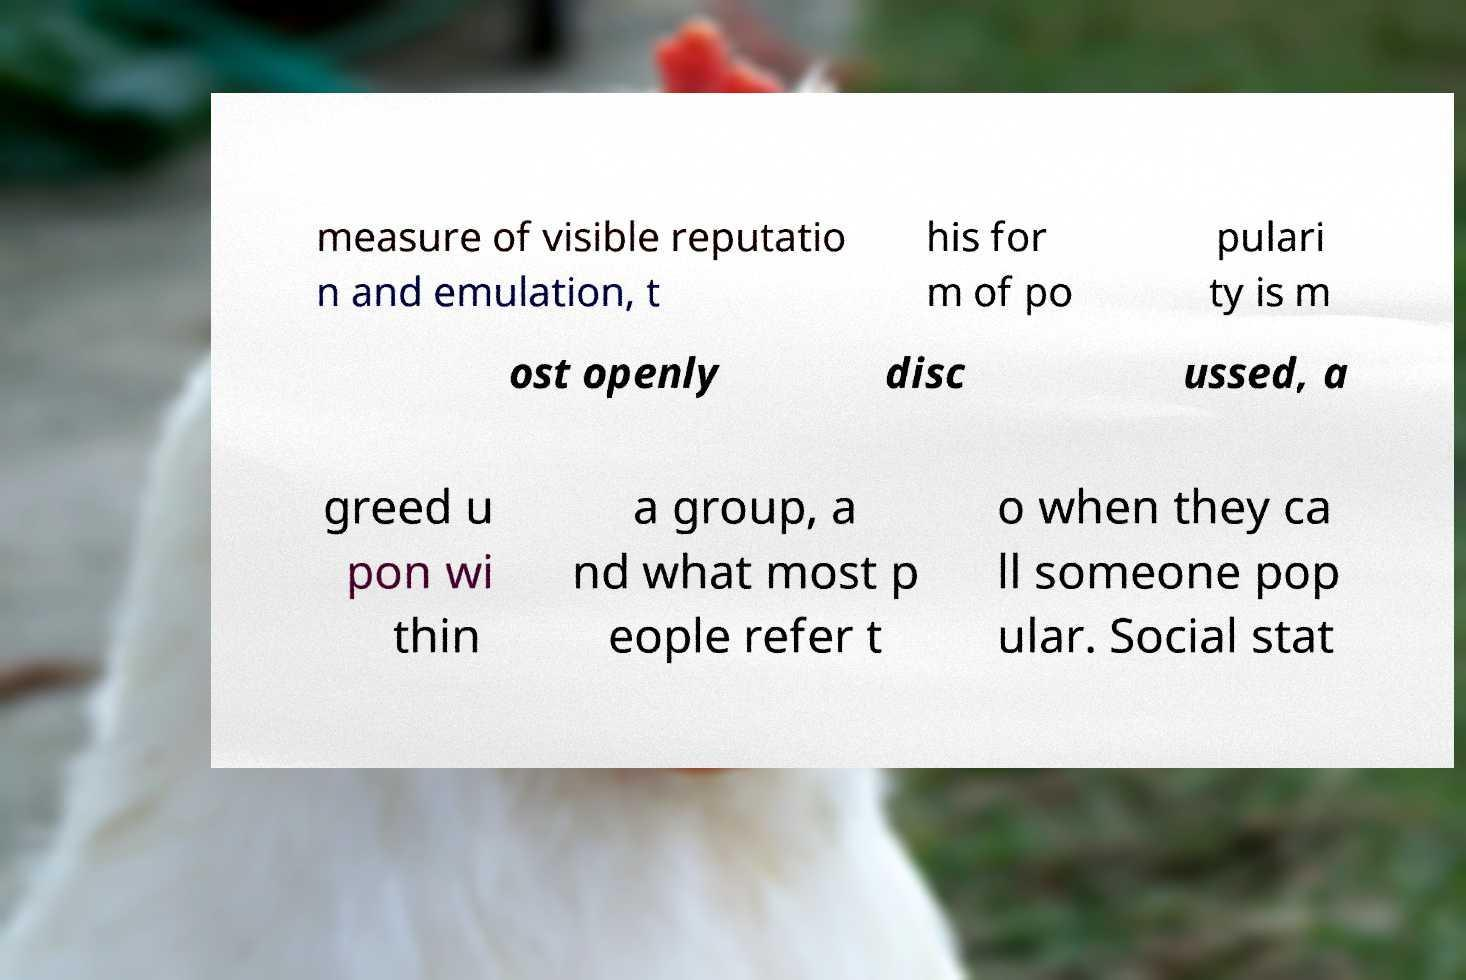Could you assist in decoding the text presented in this image and type it out clearly? measure of visible reputatio n and emulation, t his for m of po pulari ty is m ost openly disc ussed, a greed u pon wi thin a group, a nd what most p eople refer t o when they ca ll someone pop ular. Social stat 